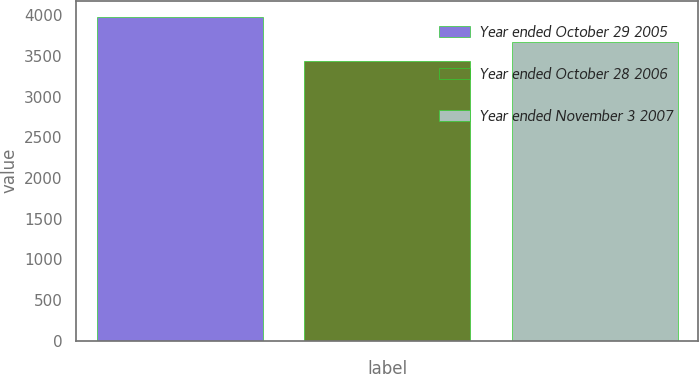<chart> <loc_0><loc_0><loc_500><loc_500><bar_chart><fcel>Year ended October 29 2005<fcel>Year ended October 28 2006<fcel>Year ended November 3 2007<nl><fcel>3979<fcel>3436<fcel>3675<nl></chart> 